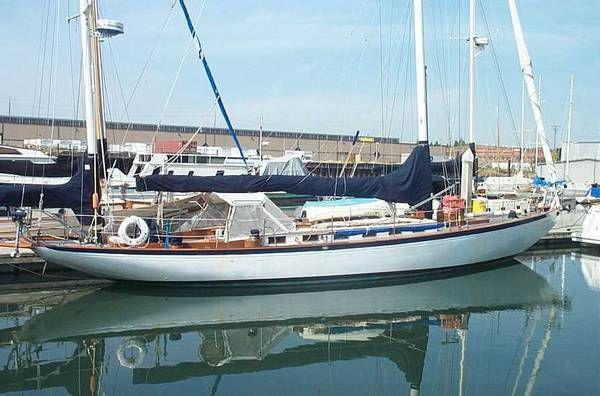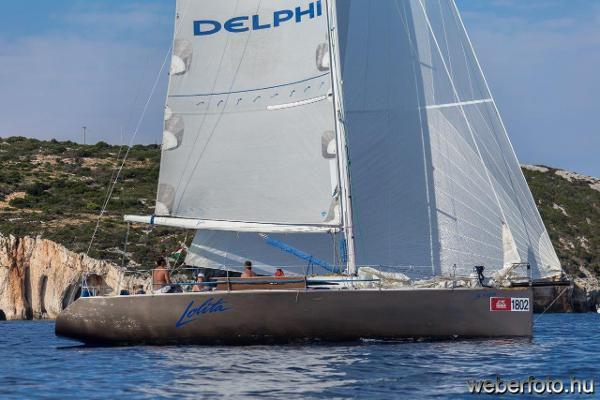The first image is the image on the left, the second image is the image on the right. For the images shown, is this caption "All images show white-bodied boats, and no boat has its sails unfurled." true? Answer yes or no. No. The first image is the image on the left, the second image is the image on the right. Analyze the images presented: Is the assertion "Both sailboats have furled white sails." valid? Answer yes or no. No. 